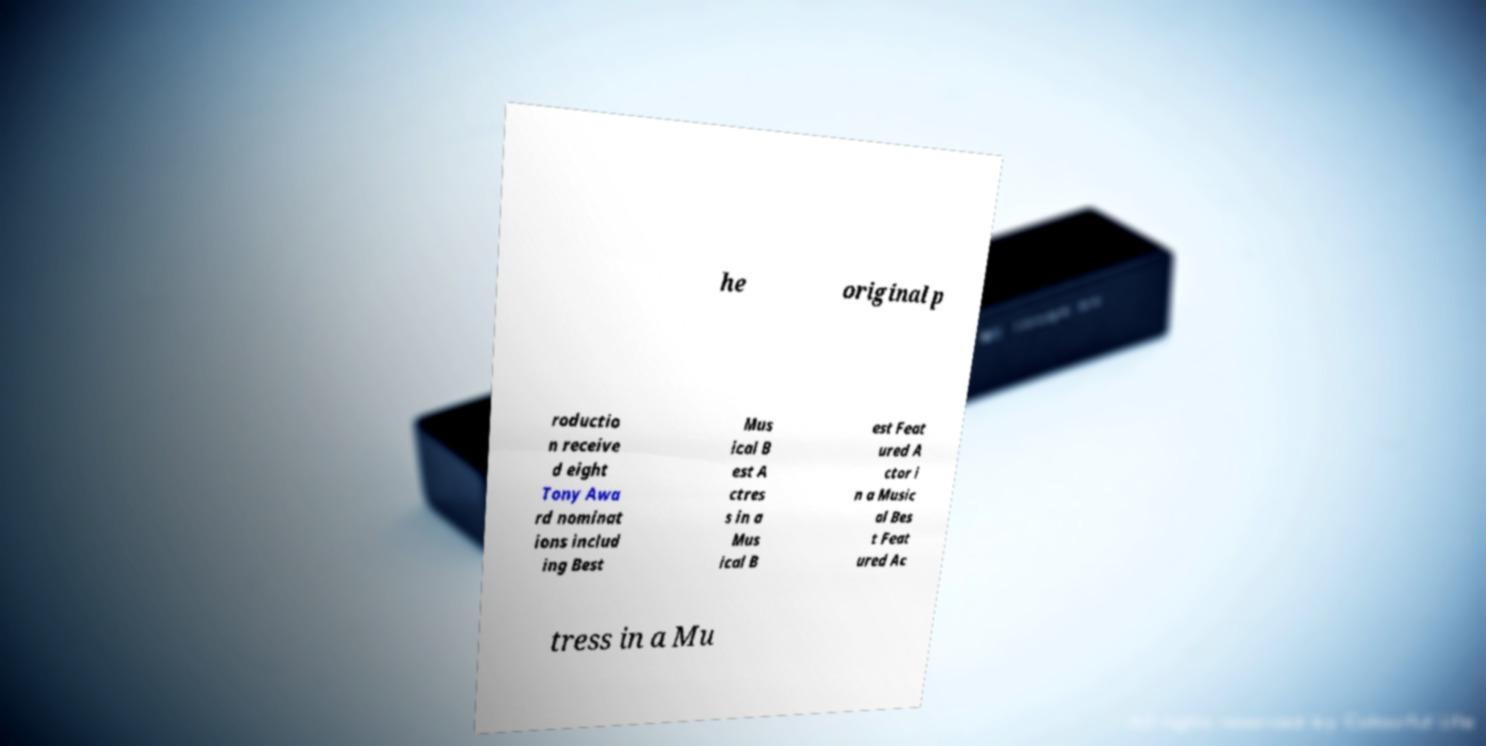There's text embedded in this image that I need extracted. Can you transcribe it verbatim? he original p roductio n receive d eight Tony Awa rd nominat ions includ ing Best Mus ical B est A ctres s in a Mus ical B est Feat ured A ctor i n a Music al Bes t Feat ured Ac tress in a Mu 